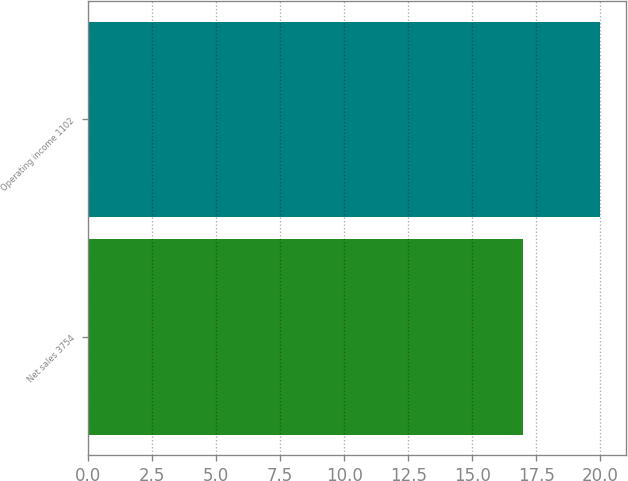<chart> <loc_0><loc_0><loc_500><loc_500><bar_chart><fcel>Net sales 3754<fcel>Operating income 1102<nl><fcel>17<fcel>20<nl></chart> 